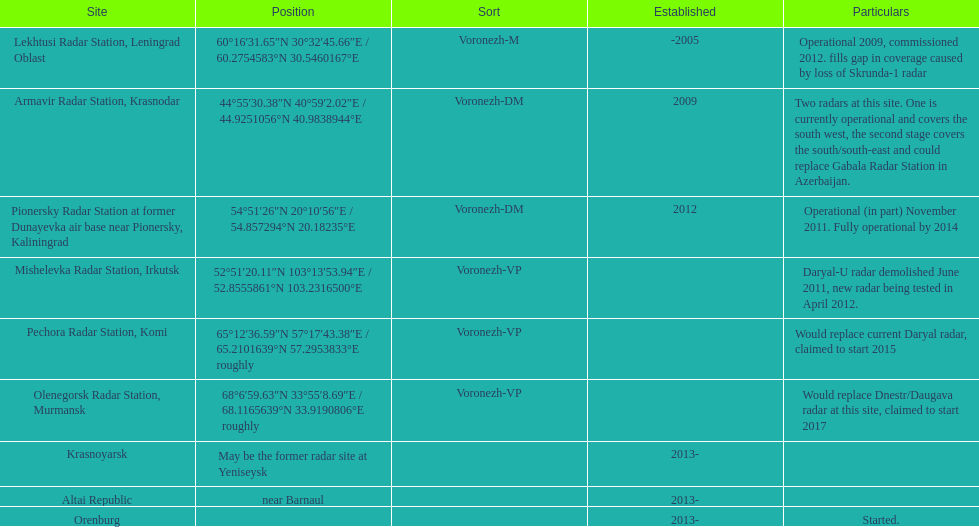What is the only location with a coordination of 60°16&#8242;31.65&#8243;n 30°32&#8242;45.66&#8243;e / 60.2754583°n 30.5460167°e? Lekhtusi Radar Station, Leningrad Oblast. 